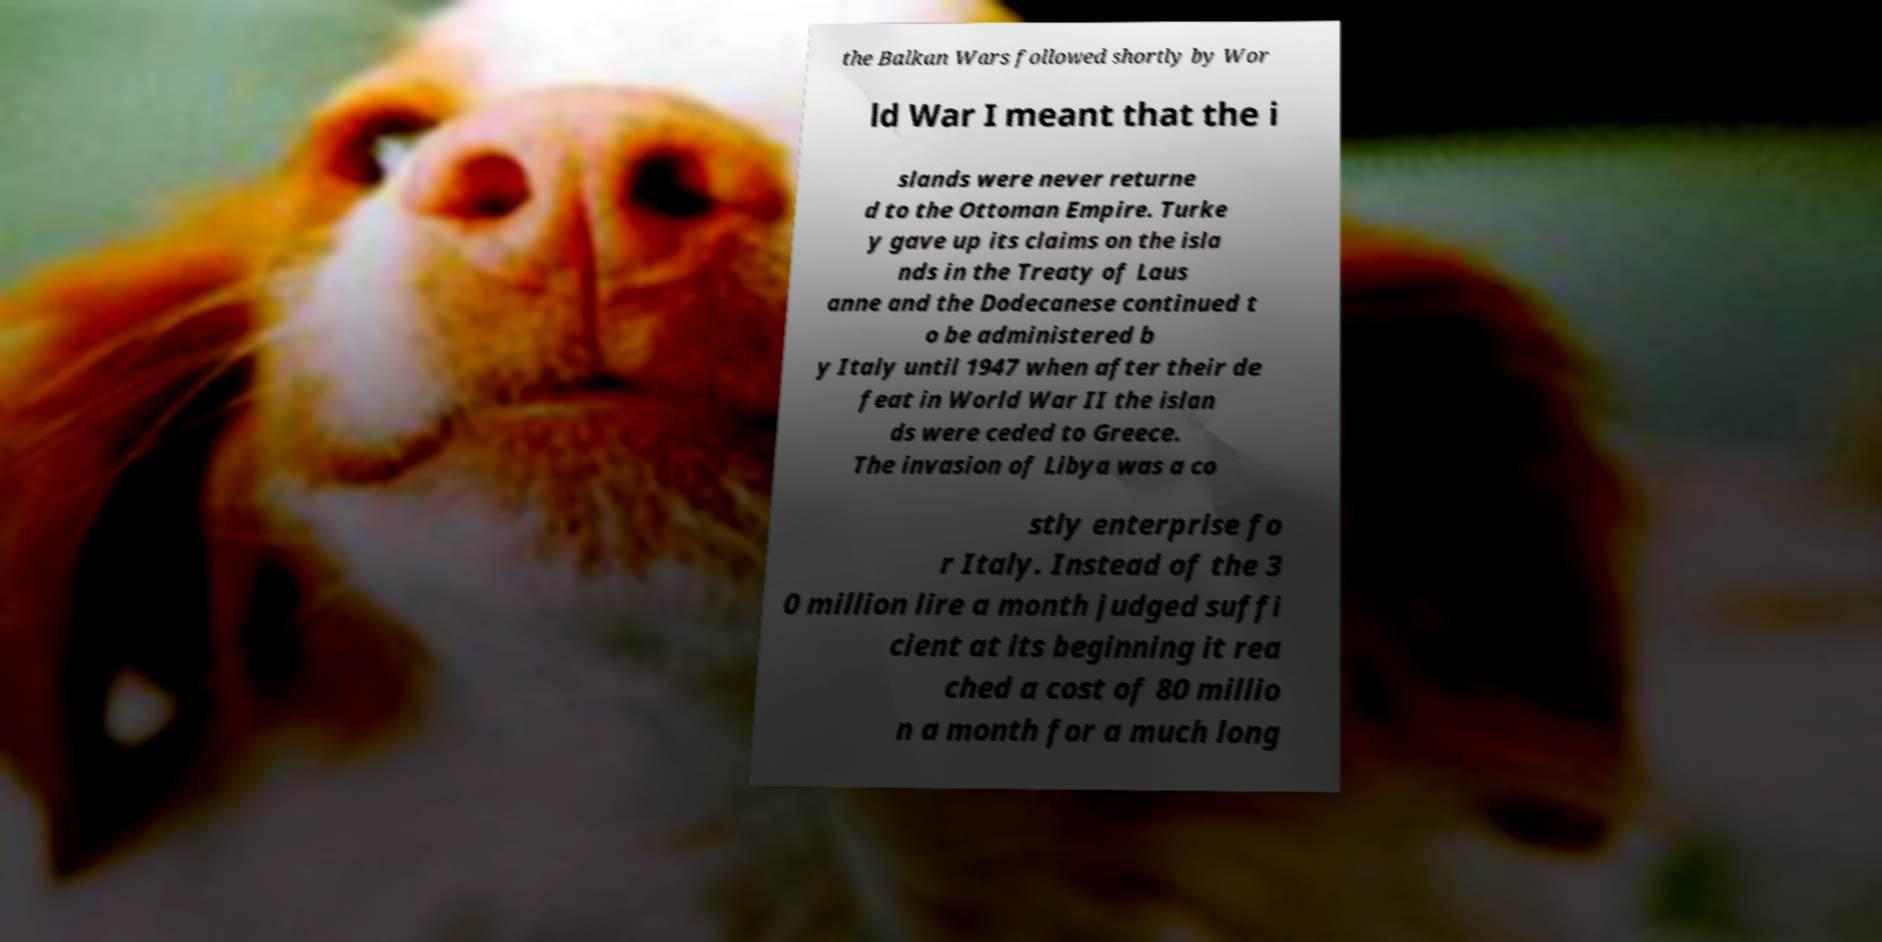I need the written content from this picture converted into text. Can you do that? the Balkan Wars followed shortly by Wor ld War I meant that the i slands were never returne d to the Ottoman Empire. Turke y gave up its claims on the isla nds in the Treaty of Laus anne and the Dodecanese continued t o be administered b y Italy until 1947 when after their de feat in World War II the islan ds were ceded to Greece. The invasion of Libya was a co stly enterprise fo r Italy. Instead of the 3 0 million lire a month judged suffi cient at its beginning it rea ched a cost of 80 millio n a month for a much long 